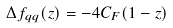Convert formula to latex. <formula><loc_0><loc_0><loc_500><loc_500>\Delta f _ { q q } ( z ) = - 4 C _ { F } ( 1 - z )</formula> 